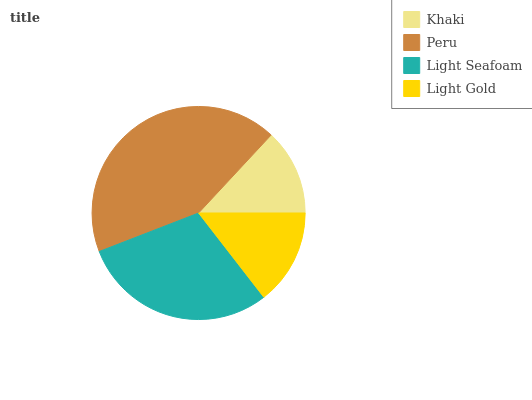Is Khaki the minimum?
Answer yes or no. Yes. Is Peru the maximum?
Answer yes or no. Yes. Is Light Seafoam the minimum?
Answer yes or no. No. Is Light Seafoam the maximum?
Answer yes or no. No. Is Peru greater than Light Seafoam?
Answer yes or no. Yes. Is Light Seafoam less than Peru?
Answer yes or no. Yes. Is Light Seafoam greater than Peru?
Answer yes or no. No. Is Peru less than Light Seafoam?
Answer yes or no. No. Is Light Seafoam the high median?
Answer yes or no. Yes. Is Light Gold the low median?
Answer yes or no. Yes. Is Khaki the high median?
Answer yes or no. No. Is Khaki the low median?
Answer yes or no. No. 